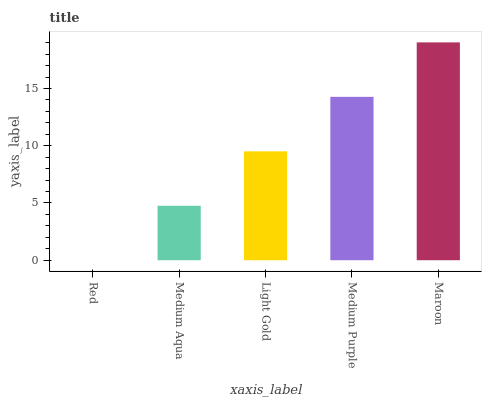Is Red the minimum?
Answer yes or no. Yes. Is Maroon the maximum?
Answer yes or no. Yes. Is Medium Aqua the minimum?
Answer yes or no. No. Is Medium Aqua the maximum?
Answer yes or no. No. Is Medium Aqua greater than Red?
Answer yes or no. Yes. Is Red less than Medium Aqua?
Answer yes or no. Yes. Is Red greater than Medium Aqua?
Answer yes or no. No. Is Medium Aqua less than Red?
Answer yes or no. No. Is Light Gold the high median?
Answer yes or no. Yes. Is Light Gold the low median?
Answer yes or no. Yes. Is Maroon the high median?
Answer yes or no. No. Is Medium Aqua the low median?
Answer yes or no. No. 